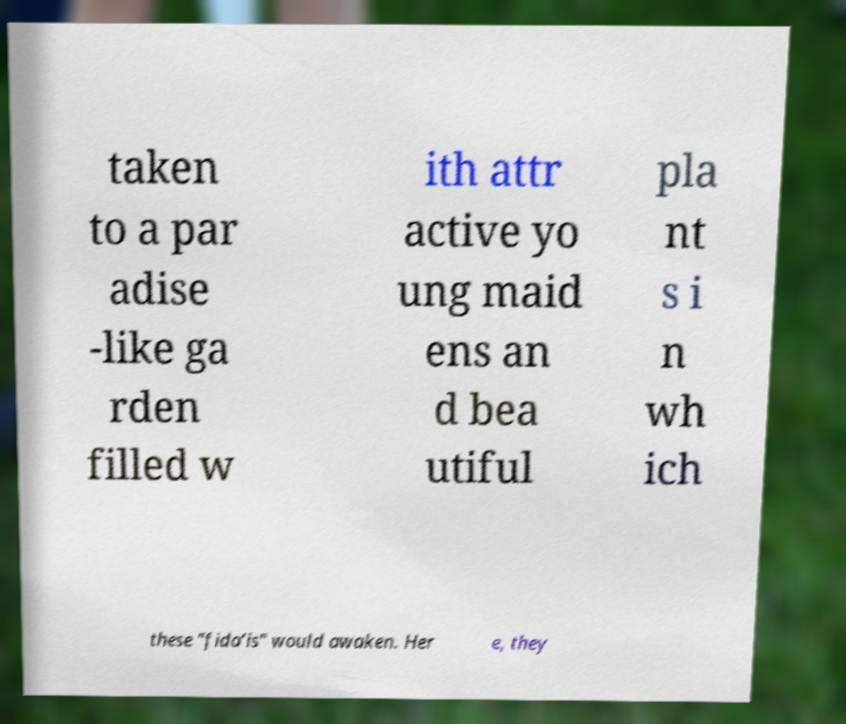What messages or text are displayed in this image? I need them in a readable, typed format. taken to a par adise -like ga rden filled w ith attr active yo ung maid ens an d bea utiful pla nt s i n wh ich these "fida’is" would awaken. Her e, they 